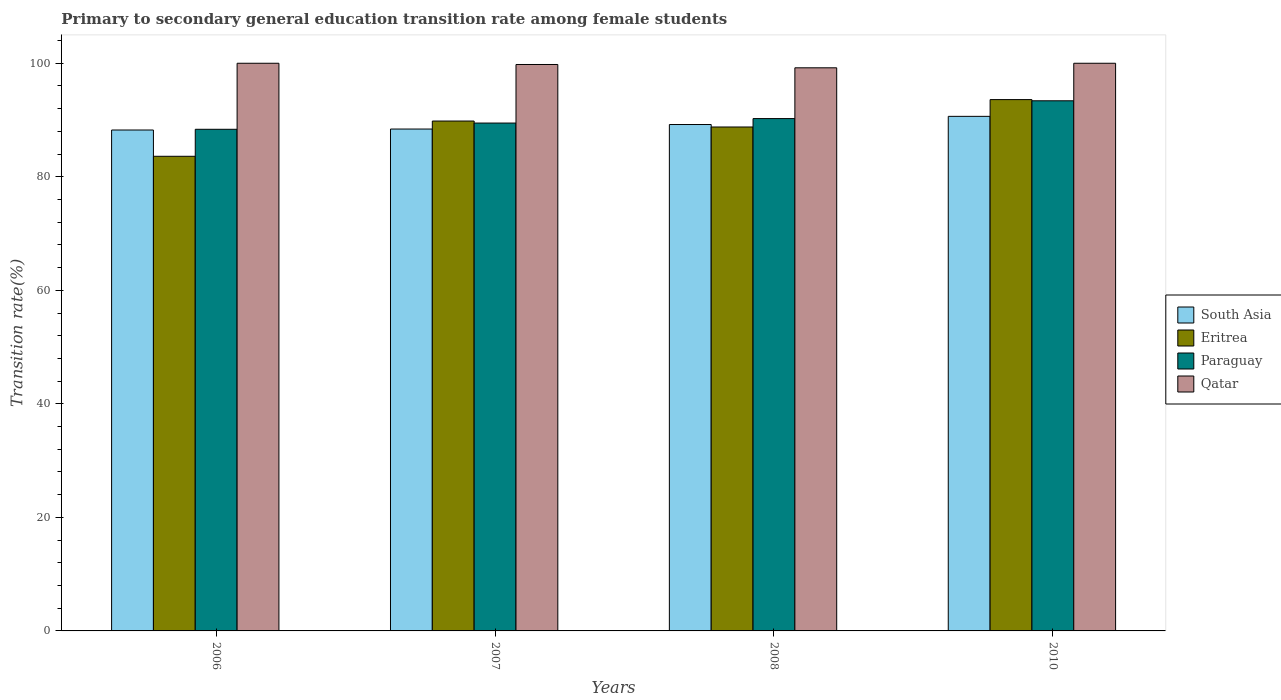How many different coloured bars are there?
Ensure brevity in your answer.  4. Are the number of bars on each tick of the X-axis equal?
Ensure brevity in your answer.  Yes. How many bars are there on the 2nd tick from the left?
Offer a terse response. 4. How many bars are there on the 1st tick from the right?
Ensure brevity in your answer.  4. What is the label of the 4th group of bars from the left?
Make the answer very short. 2010. What is the transition rate in Paraguay in 2006?
Offer a very short reply. 88.37. Across all years, what is the minimum transition rate in South Asia?
Ensure brevity in your answer.  88.24. What is the total transition rate in Qatar in the graph?
Your answer should be very brief. 398.98. What is the difference between the transition rate in Eritrea in 2008 and that in 2010?
Offer a terse response. -4.82. What is the difference between the transition rate in Paraguay in 2008 and the transition rate in Eritrea in 2006?
Make the answer very short. 6.64. What is the average transition rate in Paraguay per year?
Your response must be concise. 90.37. In the year 2008, what is the difference between the transition rate in Qatar and transition rate in South Asia?
Offer a very short reply. 9.99. In how many years, is the transition rate in Eritrea greater than 36 %?
Keep it short and to the point. 4. What is the ratio of the transition rate in Paraguay in 2006 to that in 2007?
Make the answer very short. 0.99. What is the difference between the highest and the second highest transition rate in South Asia?
Your answer should be compact. 1.44. What is the difference between the highest and the lowest transition rate in Eritrea?
Make the answer very short. 9.99. In how many years, is the transition rate in Qatar greater than the average transition rate in Qatar taken over all years?
Provide a succinct answer. 3. What does the 3rd bar from the right in 2006 represents?
Keep it short and to the point. Eritrea. Are all the bars in the graph horizontal?
Ensure brevity in your answer.  No. How many years are there in the graph?
Keep it short and to the point. 4. What is the difference between two consecutive major ticks on the Y-axis?
Offer a terse response. 20. Are the values on the major ticks of Y-axis written in scientific E-notation?
Your response must be concise. No. Does the graph contain any zero values?
Your answer should be very brief. No. Does the graph contain grids?
Give a very brief answer. No. Where does the legend appear in the graph?
Ensure brevity in your answer.  Center right. How many legend labels are there?
Your answer should be very brief. 4. What is the title of the graph?
Your answer should be compact. Primary to secondary general education transition rate among female students. Does "Slovak Republic" appear as one of the legend labels in the graph?
Keep it short and to the point. No. What is the label or title of the Y-axis?
Give a very brief answer. Transition rate(%). What is the Transition rate(%) in South Asia in 2006?
Make the answer very short. 88.24. What is the Transition rate(%) of Eritrea in 2006?
Your response must be concise. 83.61. What is the Transition rate(%) in Paraguay in 2006?
Make the answer very short. 88.37. What is the Transition rate(%) of Qatar in 2006?
Your answer should be compact. 100. What is the Transition rate(%) in South Asia in 2007?
Ensure brevity in your answer.  88.41. What is the Transition rate(%) in Eritrea in 2007?
Offer a very short reply. 89.82. What is the Transition rate(%) of Paraguay in 2007?
Keep it short and to the point. 89.47. What is the Transition rate(%) of Qatar in 2007?
Your response must be concise. 99.78. What is the Transition rate(%) of South Asia in 2008?
Your response must be concise. 89.21. What is the Transition rate(%) of Eritrea in 2008?
Keep it short and to the point. 88.77. What is the Transition rate(%) of Paraguay in 2008?
Keep it short and to the point. 90.25. What is the Transition rate(%) of Qatar in 2008?
Offer a terse response. 99.2. What is the Transition rate(%) of South Asia in 2010?
Offer a very short reply. 90.65. What is the Transition rate(%) in Eritrea in 2010?
Offer a terse response. 93.6. What is the Transition rate(%) in Paraguay in 2010?
Your answer should be very brief. 93.39. What is the Transition rate(%) of Qatar in 2010?
Keep it short and to the point. 100. Across all years, what is the maximum Transition rate(%) in South Asia?
Your answer should be very brief. 90.65. Across all years, what is the maximum Transition rate(%) of Eritrea?
Your answer should be very brief. 93.6. Across all years, what is the maximum Transition rate(%) in Paraguay?
Offer a very short reply. 93.39. Across all years, what is the minimum Transition rate(%) of South Asia?
Your answer should be compact. 88.24. Across all years, what is the minimum Transition rate(%) in Eritrea?
Provide a succinct answer. 83.61. Across all years, what is the minimum Transition rate(%) of Paraguay?
Your answer should be compact. 88.37. Across all years, what is the minimum Transition rate(%) in Qatar?
Keep it short and to the point. 99.2. What is the total Transition rate(%) of South Asia in the graph?
Ensure brevity in your answer.  356.51. What is the total Transition rate(%) of Eritrea in the graph?
Your answer should be very brief. 355.81. What is the total Transition rate(%) in Paraguay in the graph?
Give a very brief answer. 361.48. What is the total Transition rate(%) in Qatar in the graph?
Provide a short and direct response. 398.98. What is the difference between the Transition rate(%) in South Asia in 2006 and that in 2007?
Keep it short and to the point. -0.17. What is the difference between the Transition rate(%) in Eritrea in 2006 and that in 2007?
Your answer should be very brief. -6.21. What is the difference between the Transition rate(%) of Paraguay in 2006 and that in 2007?
Keep it short and to the point. -1.1. What is the difference between the Transition rate(%) of Qatar in 2006 and that in 2007?
Offer a terse response. 0.22. What is the difference between the Transition rate(%) of South Asia in 2006 and that in 2008?
Provide a short and direct response. -0.97. What is the difference between the Transition rate(%) of Eritrea in 2006 and that in 2008?
Offer a very short reply. -5.16. What is the difference between the Transition rate(%) in Paraguay in 2006 and that in 2008?
Your answer should be compact. -1.88. What is the difference between the Transition rate(%) of Qatar in 2006 and that in 2008?
Ensure brevity in your answer.  0.8. What is the difference between the Transition rate(%) of South Asia in 2006 and that in 2010?
Make the answer very short. -2.41. What is the difference between the Transition rate(%) of Eritrea in 2006 and that in 2010?
Your answer should be compact. -9.99. What is the difference between the Transition rate(%) of Paraguay in 2006 and that in 2010?
Offer a terse response. -5.02. What is the difference between the Transition rate(%) of Qatar in 2006 and that in 2010?
Offer a very short reply. 0. What is the difference between the Transition rate(%) in South Asia in 2007 and that in 2008?
Your response must be concise. -0.8. What is the difference between the Transition rate(%) in Eritrea in 2007 and that in 2008?
Your answer should be very brief. 1.05. What is the difference between the Transition rate(%) of Paraguay in 2007 and that in 2008?
Make the answer very short. -0.79. What is the difference between the Transition rate(%) of Qatar in 2007 and that in 2008?
Give a very brief answer. 0.58. What is the difference between the Transition rate(%) of South Asia in 2007 and that in 2010?
Give a very brief answer. -2.24. What is the difference between the Transition rate(%) of Eritrea in 2007 and that in 2010?
Give a very brief answer. -3.78. What is the difference between the Transition rate(%) of Paraguay in 2007 and that in 2010?
Your response must be concise. -3.92. What is the difference between the Transition rate(%) in Qatar in 2007 and that in 2010?
Make the answer very short. -0.22. What is the difference between the Transition rate(%) in South Asia in 2008 and that in 2010?
Give a very brief answer. -1.44. What is the difference between the Transition rate(%) in Eritrea in 2008 and that in 2010?
Offer a terse response. -4.82. What is the difference between the Transition rate(%) in Paraguay in 2008 and that in 2010?
Your answer should be very brief. -3.13. What is the difference between the Transition rate(%) in Qatar in 2008 and that in 2010?
Offer a very short reply. -0.8. What is the difference between the Transition rate(%) of South Asia in 2006 and the Transition rate(%) of Eritrea in 2007?
Give a very brief answer. -1.58. What is the difference between the Transition rate(%) of South Asia in 2006 and the Transition rate(%) of Paraguay in 2007?
Provide a succinct answer. -1.23. What is the difference between the Transition rate(%) of South Asia in 2006 and the Transition rate(%) of Qatar in 2007?
Offer a very short reply. -11.54. What is the difference between the Transition rate(%) in Eritrea in 2006 and the Transition rate(%) in Paraguay in 2007?
Give a very brief answer. -5.85. What is the difference between the Transition rate(%) in Eritrea in 2006 and the Transition rate(%) in Qatar in 2007?
Ensure brevity in your answer.  -16.17. What is the difference between the Transition rate(%) of Paraguay in 2006 and the Transition rate(%) of Qatar in 2007?
Your answer should be compact. -11.41. What is the difference between the Transition rate(%) in South Asia in 2006 and the Transition rate(%) in Eritrea in 2008?
Offer a very short reply. -0.53. What is the difference between the Transition rate(%) of South Asia in 2006 and the Transition rate(%) of Paraguay in 2008?
Your response must be concise. -2.01. What is the difference between the Transition rate(%) of South Asia in 2006 and the Transition rate(%) of Qatar in 2008?
Your answer should be compact. -10.96. What is the difference between the Transition rate(%) in Eritrea in 2006 and the Transition rate(%) in Paraguay in 2008?
Offer a terse response. -6.64. What is the difference between the Transition rate(%) in Eritrea in 2006 and the Transition rate(%) in Qatar in 2008?
Provide a short and direct response. -15.59. What is the difference between the Transition rate(%) in Paraguay in 2006 and the Transition rate(%) in Qatar in 2008?
Provide a short and direct response. -10.83. What is the difference between the Transition rate(%) of South Asia in 2006 and the Transition rate(%) of Eritrea in 2010?
Provide a succinct answer. -5.36. What is the difference between the Transition rate(%) in South Asia in 2006 and the Transition rate(%) in Paraguay in 2010?
Give a very brief answer. -5.15. What is the difference between the Transition rate(%) in South Asia in 2006 and the Transition rate(%) in Qatar in 2010?
Make the answer very short. -11.76. What is the difference between the Transition rate(%) in Eritrea in 2006 and the Transition rate(%) in Paraguay in 2010?
Make the answer very short. -9.78. What is the difference between the Transition rate(%) in Eritrea in 2006 and the Transition rate(%) in Qatar in 2010?
Provide a short and direct response. -16.39. What is the difference between the Transition rate(%) in Paraguay in 2006 and the Transition rate(%) in Qatar in 2010?
Your answer should be compact. -11.63. What is the difference between the Transition rate(%) of South Asia in 2007 and the Transition rate(%) of Eritrea in 2008?
Keep it short and to the point. -0.36. What is the difference between the Transition rate(%) in South Asia in 2007 and the Transition rate(%) in Paraguay in 2008?
Offer a terse response. -1.84. What is the difference between the Transition rate(%) in South Asia in 2007 and the Transition rate(%) in Qatar in 2008?
Provide a succinct answer. -10.79. What is the difference between the Transition rate(%) in Eritrea in 2007 and the Transition rate(%) in Paraguay in 2008?
Provide a succinct answer. -0.43. What is the difference between the Transition rate(%) in Eritrea in 2007 and the Transition rate(%) in Qatar in 2008?
Your answer should be very brief. -9.38. What is the difference between the Transition rate(%) of Paraguay in 2007 and the Transition rate(%) of Qatar in 2008?
Ensure brevity in your answer.  -9.73. What is the difference between the Transition rate(%) in South Asia in 2007 and the Transition rate(%) in Eritrea in 2010?
Make the answer very short. -5.19. What is the difference between the Transition rate(%) of South Asia in 2007 and the Transition rate(%) of Paraguay in 2010?
Offer a very short reply. -4.98. What is the difference between the Transition rate(%) in South Asia in 2007 and the Transition rate(%) in Qatar in 2010?
Your answer should be compact. -11.59. What is the difference between the Transition rate(%) in Eritrea in 2007 and the Transition rate(%) in Paraguay in 2010?
Your answer should be compact. -3.57. What is the difference between the Transition rate(%) in Eritrea in 2007 and the Transition rate(%) in Qatar in 2010?
Provide a short and direct response. -10.18. What is the difference between the Transition rate(%) in Paraguay in 2007 and the Transition rate(%) in Qatar in 2010?
Keep it short and to the point. -10.53. What is the difference between the Transition rate(%) of South Asia in 2008 and the Transition rate(%) of Eritrea in 2010?
Give a very brief answer. -4.39. What is the difference between the Transition rate(%) in South Asia in 2008 and the Transition rate(%) in Paraguay in 2010?
Give a very brief answer. -4.18. What is the difference between the Transition rate(%) in South Asia in 2008 and the Transition rate(%) in Qatar in 2010?
Provide a short and direct response. -10.79. What is the difference between the Transition rate(%) of Eritrea in 2008 and the Transition rate(%) of Paraguay in 2010?
Keep it short and to the point. -4.61. What is the difference between the Transition rate(%) of Eritrea in 2008 and the Transition rate(%) of Qatar in 2010?
Your answer should be compact. -11.23. What is the difference between the Transition rate(%) of Paraguay in 2008 and the Transition rate(%) of Qatar in 2010?
Give a very brief answer. -9.75. What is the average Transition rate(%) in South Asia per year?
Give a very brief answer. 89.13. What is the average Transition rate(%) in Eritrea per year?
Offer a terse response. 88.95. What is the average Transition rate(%) in Paraguay per year?
Your answer should be very brief. 90.37. What is the average Transition rate(%) in Qatar per year?
Your response must be concise. 99.75. In the year 2006, what is the difference between the Transition rate(%) in South Asia and Transition rate(%) in Eritrea?
Offer a very short reply. 4.63. In the year 2006, what is the difference between the Transition rate(%) of South Asia and Transition rate(%) of Paraguay?
Your answer should be very brief. -0.13. In the year 2006, what is the difference between the Transition rate(%) in South Asia and Transition rate(%) in Qatar?
Provide a short and direct response. -11.76. In the year 2006, what is the difference between the Transition rate(%) of Eritrea and Transition rate(%) of Paraguay?
Provide a succinct answer. -4.76. In the year 2006, what is the difference between the Transition rate(%) in Eritrea and Transition rate(%) in Qatar?
Provide a short and direct response. -16.39. In the year 2006, what is the difference between the Transition rate(%) of Paraguay and Transition rate(%) of Qatar?
Your answer should be compact. -11.63. In the year 2007, what is the difference between the Transition rate(%) of South Asia and Transition rate(%) of Eritrea?
Your answer should be very brief. -1.41. In the year 2007, what is the difference between the Transition rate(%) in South Asia and Transition rate(%) in Paraguay?
Make the answer very short. -1.05. In the year 2007, what is the difference between the Transition rate(%) of South Asia and Transition rate(%) of Qatar?
Your response must be concise. -11.37. In the year 2007, what is the difference between the Transition rate(%) of Eritrea and Transition rate(%) of Paraguay?
Provide a short and direct response. 0.36. In the year 2007, what is the difference between the Transition rate(%) of Eritrea and Transition rate(%) of Qatar?
Your answer should be very brief. -9.96. In the year 2007, what is the difference between the Transition rate(%) of Paraguay and Transition rate(%) of Qatar?
Give a very brief answer. -10.32. In the year 2008, what is the difference between the Transition rate(%) in South Asia and Transition rate(%) in Eritrea?
Your answer should be compact. 0.43. In the year 2008, what is the difference between the Transition rate(%) of South Asia and Transition rate(%) of Paraguay?
Your answer should be compact. -1.05. In the year 2008, what is the difference between the Transition rate(%) in South Asia and Transition rate(%) in Qatar?
Ensure brevity in your answer.  -9.99. In the year 2008, what is the difference between the Transition rate(%) of Eritrea and Transition rate(%) of Paraguay?
Keep it short and to the point. -1.48. In the year 2008, what is the difference between the Transition rate(%) of Eritrea and Transition rate(%) of Qatar?
Make the answer very short. -10.42. In the year 2008, what is the difference between the Transition rate(%) in Paraguay and Transition rate(%) in Qatar?
Your response must be concise. -8.94. In the year 2010, what is the difference between the Transition rate(%) of South Asia and Transition rate(%) of Eritrea?
Make the answer very short. -2.95. In the year 2010, what is the difference between the Transition rate(%) of South Asia and Transition rate(%) of Paraguay?
Your response must be concise. -2.74. In the year 2010, what is the difference between the Transition rate(%) in South Asia and Transition rate(%) in Qatar?
Give a very brief answer. -9.35. In the year 2010, what is the difference between the Transition rate(%) of Eritrea and Transition rate(%) of Paraguay?
Your response must be concise. 0.21. In the year 2010, what is the difference between the Transition rate(%) of Eritrea and Transition rate(%) of Qatar?
Make the answer very short. -6.4. In the year 2010, what is the difference between the Transition rate(%) in Paraguay and Transition rate(%) in Qatar?
Provide a short and direct response. -6.61. What is the ratio of the Transition rate(%) of Eritrea in 2006 to that in 2007?
Offer a terse response. 0.93. What is the ratio of the Transition rate(%) of Paraguay in 2006 to that in 2007?
Provide a short and direct response. 0.99. What is the ratio of the Transition rate(%) of South Asia in 2006 to that in 2008?
Your answer should be very brief. 0.99. What is the ratio of the Transition rate(%) in Eritrea in 2006 to that in 2008?
Your answer should be compact. 0.94. What is the ratio of the Transition rate(%) of Paraguay in 2006 to that in 2008?
Provide a short and direct response. 0.98. What is the ratio of the Transition rate(%) of South Asia in 2006 to that in 2010?
Keep it short and to the point. 0.97. What is the ratio of the Transition rate(%) of Eritrea in 2006 to that in 2010?
Make the answer very short. 0.89. What is the ratio of the Transition rate(%) of Paraguay in 2006 to that in 2010?
Keep it short and to the point. 0.95. What is the ratio of the Transition rate(%) in South Asia in 2007 to that in 2008?
Provide a short and direct response. 0.99. What is the ratio of the Transition rate(%) in Eritrea in 2007 to that in 2008?
Provide a short and direct response. 1.01. What is the ratio of the Transition rate(%) in Qatar in 2007 to that in 2008?
Provide a short and direct response. 1.01. What is the ratio of the Transition rate(%) of South Asia in 2007 to that in 2010?
Offer a very short reply. 0.98. What is the ratio of the Transition rate(%) of Eritrea in 2007 to that in 2010?
Ensure brevity in your answer.  0.96. What is the ratio of the Transition rate(%) in Paraguay in 2007 to that in 2010?
Provide a succinct answer. 0.96. What is the ratio of the Transition rate(%) of Qatar in 2007 to that in 2010?
Ensure brevity in your answer.  1. What is the ratio of the Transition rate(%) in South Asia in 2008 to that in 2010?
Your response must be concise. 0.98. What is the ratio of the Transition rate(%) in Eritrea in 2008 to that in 2010?
Give a very brief answer. 0.95. What is the ratio of the Transition rate(%) of Paraguay in 2008 to that in 2010?
Offer a terse response. 0.97. What is the difference between the highest and the second highest Transition rate(%) of South Asia?
Your response must be concise. 1.44. What is the difference between the highest and the second highest Transition rate(%) of Eritrea?
Provide a short and direct response. 3.78. What is the difference between the highest and the second highest Transition rate(%) of Paraguay?
Keep it short and to the point. 3.13. What is the difference between the highest and the lowest Transition rate(%) of South Asia?
Your response must be concise. 2.41. What is the difference between the highest and the lowest Transition rate(%) of Eritrea?
Your answer should be compact. 9.99. What is the difference between the highest and the lowest Transition rate(%) of Paraguay?
Your response must be concise. 5.02. What is the difference between the highest and the lowest Transition rate(%) in Qatar?
Provide a succinct answer. 0.8. 